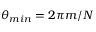<formula> <loc_0><loc_0><loc_500><loc_500>\theta _ { \min } = 2 \pi m / N</formula> 